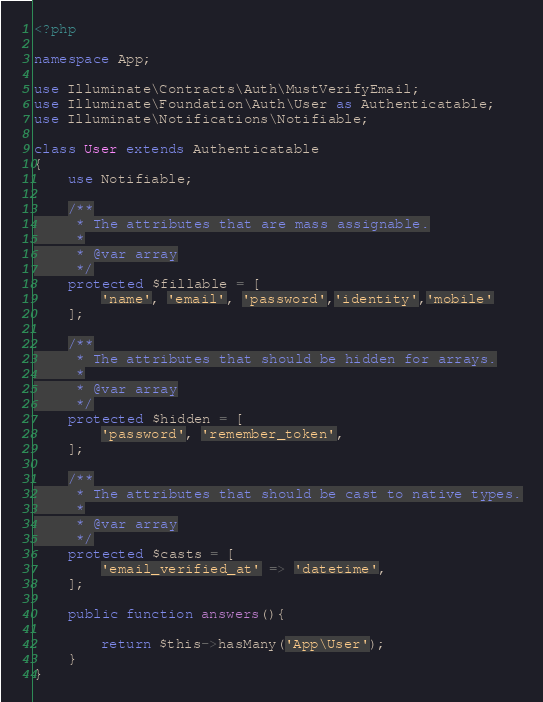Convert code to text. <code><loc_0><loc_0><loc_500><loc_500><_PHP_><?php

namespace App;

use Illuminate\Contracts\Auth\MustVerifyEmail;
use Illuminate\Foundation\Auth\User as Authenticatable;
use Illuminate\Notifications\Notifiable;

class User extends Authenticatable
{
    use Notifiable;

    /**
     * The attributes that are mass assignable.
     *
     * @var array
     */
    protected $fillable = [
        'name', 'email', 'password','identity','mobile'
    ];

    /**
     * The attributes that should be hidden for arrays.
     *
     * @var array
     */
    protected $hidden = [
        'password', 'remember_token',
    ];

    /**
     * The attributes that should be cast to native types.
     *
     * @var array
     */
    protected $casts = [
        'email_verified_at' => 'datetime',
    ];

    public function answers(){

        return $this->hasMany('App\User');
    }
}
</code> 